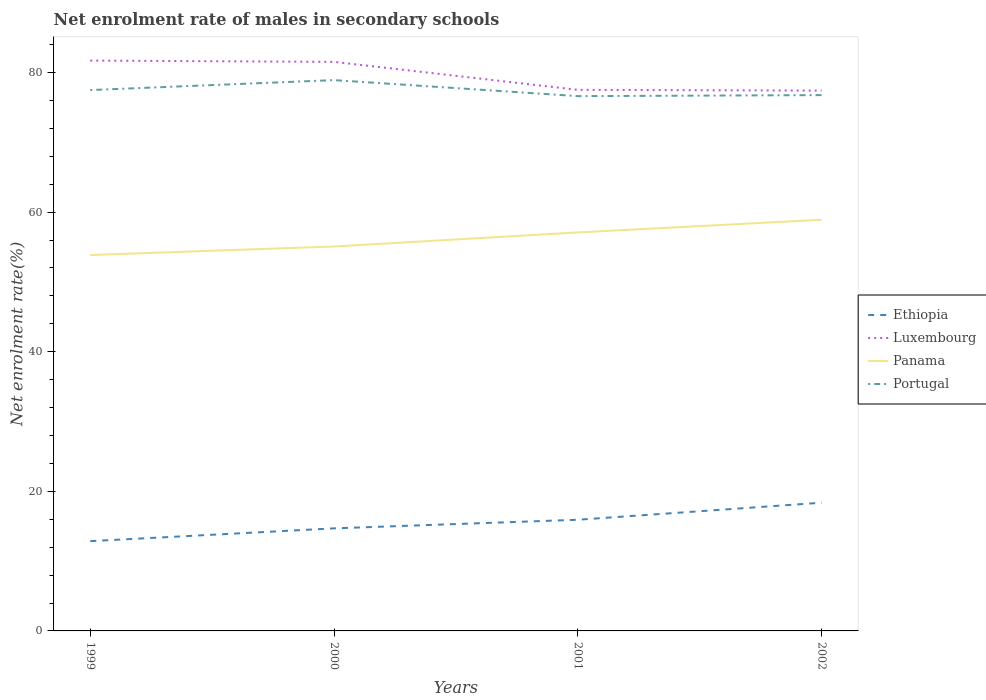Does the line corresponding to Panama intersect with the line corresponding to Portugal?
Provide a succinct answer. No. Is the number of lines equal to the number of legend labels?
Offer a very short reply. Yes. Across all years, what is the maximum net enrolment rate of males in secondary schools in Luxembourg?
Your answer should be compact. 77.42. What is the total net enrolment rate of males in secondary schools in Luxembourg in the graph?
Provide a short and direct response. 0.11. What is the difference between the highest and the second highest net enrolment rate of males in secondary schools in Ethiopia?
Offer a terse response. 5.51. What is the difference between the highest and the lowest net enrolment rate of males in secondary schools in Panama?
Your answer should be compact. 2. Is the net enrolment rate of males in secondary schools in Luxembourg strictly greater than the net enrolment rate of males in secondary schools in Portugal over the years?
Keep it short and to the point. No. What is the difference between two consecutive major ticks on the Y-axis?
Ensure brevity in your answer.  20. Does the graph contain any zero values?
Make the answer very short. No. Does the graph contain grids?
Provide a succinct answer. No. Where does the legend appear in the graph?
Make the answer very short. Center right. How are the legend labels stacked?
Give a very brief answer. Vertical. What is the title of the graph?
Your answer should be compact. Net enrolment rate of males in secondary schools. What is the label or title of the X-axis?
Give a very brief answer. Years. What is the label or title of the Y-axis?
Make the answer very short. Net enrolment rate(%). What is the Net enrolment rate(%) of Ethiopia in 1999?
Your answer should be compact. 12.86. What is the Net enrolment rate(%) of Luxembourg in 1999?
Make the answer very short. 81.71. What is the Net enrolment rate(%) in Panama in 1999?
Offer a very short reply. 53.86. What is the Net enrolment rate(%) in Portugal in 1999?
Your answer should be compact. 77.49. What is the Net enrolment rate(%) of Ethiopia in 2000?
Keep it short and to the point. 14.7. What is the Net enrolment rate(%) in Luxembourg in 2000?
Offer a terse response. 81.53. What is the Net enrolment rate(%) of Panama in 2000?
Your response must be concise. 55.08. What is the Net enrolment rate(%) of Portugal in 2000?
Give a very brief answer. 78.92. What is the Net enrolment rate(%) in Ethiopia in 2001?
Make the answer very short. 15.93. What is the Net enrolment rate(%) in Luxembourg in 2001?
Ensure brevity in your answer.  77.53. What is the Net enrolment rate(%) in Panama in 2001?
Offer a terse response. 57.1. What is the Net enrolment rate(%) in Portugal in 2001?
Offer a very short reply. 76.62. What is the Net enrolment rate(%) of Ethiopia in 2002?
Keep it short and to the point. 18.37. What is the Net enrolment rate(%) of Luxembourg in 2002?
Keep it short and to the point. 77.42. What is the Net enrolment rate(%) of Panama in 2002?
Your response must be concise. 58.91. What is the Net enrolment rate(%) in Portugal in 2002?
Provide a succinct answer. 76.77. Across all years, what is the maximum Net enrolment rate(%) of Ethiopia?
Your answer should be very brief. 18.37. Across all years, what is the maximum Net enrolment rate(%) of Luxembourg?
Provide a short and direct response. 81.71. Across all years, what is the maximum Net enrolment rate(%) in Panama?
Ensure brevity in your answer.  58.91. Across all years, what is the maximum Net enrolment rate(%) in Portugal?
Your answer should be very brief. 78.92. Across all years, what is the minimum Net enrolment rate(%) of Ethiopia?
Provide a succinct answer. 12.86. Across all years, what is the minimum Net enrolment rate(%) of Luxembourg?
Provide a succinct answer. 77.42. Across all years, what is the minimum Net enrolment rate(%) of Panama?
Your answer should be compact. 53.86. Across all years, what is the minimum Net enrolment rate(%) of Portugal?
Offer a very short reply. 76.62. What is the total Net enrolment rate(%) in Ethiopia in the graph?
Keep it short and to the point. 61.86. What is the total Net enrolment rate(%) in Luxembourg in the graph?
Offer a terse response. 318.19. What is the total Net enrolment rate(%) of Panama in the graph?
Provide a succinct answer. 224.95. What is the total Net enrolment rate(%) in Portugal in the graph?
Your answer should be compact. 309.8. What is the difference between the Net enrolment rate(%) of Ethiopia in 1999 and that in 2000?
Provide a short and direct response. -1.83. What is the difference between the Net enrolment rate(%) in Luxembourg in 1999 and that in 2000?
Keep it short and to the point. 0.18. What is the difference between the Net enrolment rate(%) of Panama in 1999 and that in 2000?
Provide a short and direct response. -1.22. What is the difference between the Net enrolment rate(%) of Portugal in 1999 and that in 2000?
Ensure brevity in your answer.  -1.43. What is the difference between the Net enrolment rate(%) in Ethiopia in 1999 and that in 2001?
Your answer should be compact. -3.07. What is the difference between the Net enrolment rate(%) of Luxembourg in 1999 and that in 2001?
Your response must be concise. 4.19. What is the difference between the Net enrolment rate(%) in Panama in 1999 and that in 2001?
Offer a terse response. -3.24. What is the difference between the Net enrolment rate(%) of Portugal in 1999 and that in 2001?
Give a very brief answer. 0.87. What is the difference between the Net enrolment rate(%) in Ethiopia in 1999 and that in 2002?
Offer a terse response. -5.51. What is the difference between the Net enrolment rate(%) of Luxembourg in 1999 and that in 2002?
Offer a very short reply. 4.3. What is the difference between the Net enrolment rate(%) in Panama in 1999 and that in 2002?
Provide a succinct answer. -5.05. What is the difference between the Net enrolment rate(%) in Portugal in 1999 and that in 2002?
Provide a short and direct response. 0.72. What is the difference between the Net enrolment rate(%) in Ethiopia in 2000 and that in 2001?
Your answer should be compact. -1.23. What is the difference between the Net enrolment rate(%) in Luxembourg in 2000 and that in 2001?
Your response must be concise. 4.01. What is the difference between the Net enrolment rate(%) in Panama in 2000 and that in 2001?
Your answer should be very brief. -2.02. What is the difference between the Net enrolment rate(%) of Portugal in 2000 and that in 2001?
Ensure brevity in your answer.  2.3. What is the difference between the Net enrolment rate(%) in Ethiopia in 2000 and that in 2002?
Give a very brief answer. -3.68. What is the difference between the Net enrolment rate(%) in Luxembourg in 2000 and that in 2002?
Your response must be concise. 4.12. What is the difference between the Net enrolment rate(%) of Panama in 2000 and that in 2002?
Your answer should be compact. -3.83. What is the difference between the Net enrolment rate(%) of Portugal in 2000 and that in 2002?
Your response must be concise. 2.15. What is the difference between the Net enrolment rate(%) in Ethiopia in 2001 and that in 2002?
Provide a succinct answer. -2.44. What is the difference between the Net enrolment rate(%) in Luxembourg in 2001 and that in 2002?
Ensure brevity in your answer.  0.11. What is the difference between the Net enrolment rate(%) of Panama in 2001 and that in 2002?
Provide a short and direct response. -1.82. What is the difference between the Net enrolment rate(%) of Portugal in 2001 and that in 2002?
Give a very brief answer. -0.15. What is the difference between the Net enrolment rate(%) in Ethiopia in 1999 and the Net enrolment rate(%) in Luxembourg in 2000?
Offer a terse response. -68.67. What is the difference between the Net enrolment rate(%) of Ethiopia in 1999 and the Net enrolment rate(%) of Panama in 2000?
Ensure brevity in your answer.  -42.22. What is the difference between the Net enrolment rate(%) of Ethiopia in 1999 and the Net enrolment rate(%) of Portugal in 2000?
Offer a terse response. -66.06. What is the difference between the Net enrolment rate(%) in Luxembourg in 1999 and the Net enrolment rate(%) in Panama in 2000?
Your answer should be compact. 26.63. What is the difference between the Net enrolment rate(%) of Luxembourg in 1999 and the Net enrolment rate(%) of Portugal in 2000?
Provide a short and direct response. 2.8. What is the difference between the Net enrolment rate(%) of Panama in 1999 and the Net enrolment rate(%) of Portugal in 2000?
Provide a short and direct response. -25.06. What is the difference between the Net enrolment rate(%) in Ethiopia in 1999 and the Net enrolment rate(%) in Luxembourg in 2001?
Your response must be concise. -64.66. What is the difference between the Net enrolment rate(%) of Ethiopia in 1999 and the Net enrolment rate(%) of Panama in 2001?
Provide a short and direct response. -44.23. What is the difference between the Net enrolment rate(%) in Ethiopia in 1999 and the Net enrolment rate(%) in Portugal in 2001?
Provide a short and direct response. -63.76. What is the difference between the Net enrolment rate(%) of Luxembourg in 1999 and the Net enrolment rate(%) of Panama in 2001?
Offer a terse response. 24.62. What is the difference between the Net enrolment rate(%) in Luxembourg in 1999 and the Net enrolment rate(%) in Portugal in 2001?
Offer a terse response. 5.09. What is the difference between the Net enrolment rate(%) of Panama in 1999 and the Net enrolment rate(%) of Portugal in 2001?
Make the answer very short. -22.76. What is the difference between the Net enrolment rate(%) in Ethiopia in 1999 and the Net enrolment rate(%) in Luxembourg in 2002?
Give a very brief answer. -64.55. What is the difference between the Net enrolment rate(%) of Ethiopia in 1999 and the Net enrolment rate(%) of Panama in 2002?
Make the answer very short. -46.05. What is the difference between the Net enrolment rate(%) of Ethiopia in 1999 and the Net enrolment rate(%) of Portugal in 2002?
Keep it short and to the point. -63.91. What is the difference between the Net enrolment rate(%) of Luxembourg in 1999 and the Net enrolment rate(%) of Panama in 2002?
Keep it short and to the point. 22.8. What is the difference between the Net enrolment rate(%) in Luxembourg in 1999 and the Net enrolment rate(%) in Portugal in 2002?
Ensure brevity in your answer.  4.94. What is the difference between the Net enrolment rate(%) in Panama in 1999 and the Net enrolment rate(%) in Portugal in 2002?
Offer a terse response. -22.91. What is the difference between the Net enrolment rate(%) of Ethiopia in 2000 and the Net enrolment rate(%) of Luxembourg in 2001?
Ensure brevity in your answer.  -62.83. What is the difference between the Net enrolment rate(%) in Ethiopia in 2000 and the Net enrolment rate(%) in Panama in 2001?
Make the answer very short. -42.4. What is the difference between the Net enrolment rate(%) in Ethiopia in 2000 and the Net enrolment rate(%) in Portugal in 2001?
Offer a terse response. -61.93. What is the difference between the Net enrolment rate(%) in Luxembourg in 2000 and the Net enrolment rate(%) in Panama in 2001?
Provide a short and direct response. 24.44. What is the difference between the Net enrolment rate(%) of Luxembourg in 2000 and the Net enrolment rate(%) of Portugal in 2001?
Provide a succinct answer. 4.91. What is the difference between the Net enrolment rate(%) in Panama in 2000 and the Net enrolment rate(%) in Portugal in 2001?
Your response must be concise. -21.54. What is the difference between the Net enrolment rate(%) of Ethiopia in 2000 and the Net enrolment rate(%) of Luxembourg in 2002?
Keep it short and to the point. -62.72. What is the difference between the Net enrolment rate(%) of Ethiopia in 2000 and the Net enrolment rate(%) of Panama in 2002?
Your response must be concise. -44.22. What is the difference between the Net enrolment rate(%) in Ethiopia in 2000 and the Net enrolment rate(%) in Portugal in 2002?
Offer a very short reply. -62.08. What is the difference between the Net enrolment rate(%) of Luxembourg in 2000 and the Net enrolment rate(%) of Panama in 2002?
Ensure brevity in your answer.  22.62. What is the difference between the Net enrolment rate(%) in Luxembourg in 2000 and the Net enrolment rate(%) in Portugal in 2002?
Give a very brief answer. 4.76. What is the difference between the Net enrolment rate(%) in Panama in 2000 and the Net enrolment rate(%) in Portugal in 2002?
Ensure brevity in your answer.  -21.69. What is the difference between the Net enrolment rate(%) of Ethiopia in 2001 and the Net enrolment rate(%) of Luxembourg in 2002?
Your answer should be compact. -61.49. What is the difference between the Net enrolment rate(%) in Ethiopia in 2001 and the Net enrolment rate(%) in Panama in 2002?
Your answer should be compact. -42.98. What is the difference between the Net enrolment rate(%) in Ethiopia in 2001 and the Net enrolment rate(%) in Portugal in 2002?
Your answer should be compact. -60.84. What is the difference between the Net enrolment rate(%) of Luxembourg in 2001 and the Net enrolment rate(%) of Panama in 2002?
Ensure brevity in your answer.  18.61. What is the difference between the Net enrolment rate(%) in Luxembourg in 2001 and the Net enrolment rate(%) in Portugal in 2002?
Provide a succinct answer. 0.75. What is the difference between the Net enrolment rate(%) of Panama in 2001 and the Net enrolment rate(%) of Portugal in 2002?
Your response must be concise. -19.68. What is the average Net enrolment rate(%) in Ethiopia per year?
Offer a very short reply. 15.46. What is the average Net enrolment rate(%) in Luxembourg per year?
Ensure brevity in your answer.  79.55. What is the average Net enrolment rate(%) of Panama per year?
Your response must be concise. 56.24. What is the average Net enrolment rate(%) in Portugal per year?
Your response must be concise. 77.45. In the year 1999, what is the difference between the Net enrolment rate(%) in Ethiopia and Net enrolment rate(%) in Luxembourg?
Offer a terse response. -68.85. In the year 1999, what is the difference between the Net enrolment rate(%) of Ethiopia and Net enrolment rate(%) of Panama?
Provide a short and direct response. -41. In the year 1999, what is the difference between the Net enrolment rate(%) of Ethiopia and Net enrolment rate(%) of Portugal?
Provide a succinct answer. -64.63. In the year 1999, what is the difference between the Net enrolment rate(%) in Luxembourg and Net enrolment rate(%) in Panama?
Offer a terse response. 27.85. In the year 1999, what is the difference between the Net enrolment rate(%) of Luxembourg and Net enrolment rate(%) of Portugal?
Make the answer very short. 4.22. In the year 1999, what is the difference between the Net enrolment rate(%) of Panama and Net enrolment rate(%) of Portugal?
Provide a short and direct response. -23.63. In the year 2000, what is the difference between the Net enrolment rate(%) in Ethiopia and Net enrolment rate(%) in Luxembourg?
Your answer should be very brief. -66.84. In the year 2000, what is the difference between the Net enrolment rate(%) in Ethiopia and Net enrolment rate(%) in Panama?
Offer a very short reply. -40.38. In the year 2000, what is the difference between the Net enrolment rate(%) of Ethiopia and Net enrolment rate(%) of Portugal?
Ensure brevity in your answer.  -64.22. In the year 2000, what is the difference between the Net enrolment rate(%) in Luxembourg and Net enrolment rate(%) in Panama?
Offer a very short reply. 26.45. In the year 2000, what is the difference between the Net enrolment rate(%) in Luxembourg and Net enrolment rate(%) in Portugal?
Your answer should be very brief. 2.62. In the year 2000, what is the difference between the Net enrolment rate(%) in Panama and Net enrolment rate(%) in Portugal?
Offer a very short reply. -23.84. In the year 2001, what is the difference between the Net enrolment rate(%) of Ethiopia and Net enrolment rate(%) of Luxembourg?
Give a very brief answer. -61.6. In the year 2001, what is the difference between the Net enrolment rate(%) of Ethiopia and Net enrolment rate(%) of Panama?
Provide a short and direct response. -41.17. In the year 2001, what is the difference between the Net enrolment rate(%) of Ethiopia and Net enrolment rate(%) of Portugal?
Your response must be concise. -60.69. In the year 2001, what is the difference between the Net enrolment rate(%) in Luxembourg and Net enrolment rate(%) in Panama?
Ensure brevity in your answer.  20.43. In the year 2001, what is the difference between the Net enrolment rate(%) in Luxembourg and Net enrolment rate(%) in Portugal?
Offer a very short reply. 0.9. In the year 2001, what is the difference between the Net enrolment rate(%) of Panama and Net enrolment rate(%) of Portugal?
Provide a succinct answer. -19.53. In the year 2002, what is the difference between the Net enrolment rate(%) in Ethiopia and Net enrolment rate(%) in Luxembourg?
Your response must be concise. -59.05. In the year 2002, what is the difference between the Net enrolment rate(%) of Ethiopia and Net enrolment rate(%) of Panama?
Give a very brief answer. -40.54. In the year 2002, what is the difference between the Net enrolment rate(%) in Ethiopia and Net enrolment rate(%) in Portugal?
Keep it short and to the point. -58.4. In the year 2002, what is the difference between the Net enrolment rate(%) in Luxembourg and Net enrolment rate(%) in Panama?
Your answer should be very brief. 18.5. In the year 2002, what is the difference between the Net enrolment rate(%) of Luxembourg and Net enrolment rate(%) of Portugal?
Offer a terse response. 0.64. In the year 2002, what is the difference between the Net enrolment rate(%) in Panama and Net enrolment rate(%) in Portugal?
Provide a succinct answer. -17.86. What is the ratio of the Net enrolment rate(%) of Ethiopia in 1999 to that in 2000?
Provide a short and direct response. 0.88. What is the ratio of the Net enrolment rate(%) in Luxembourg in 1999 to that in 2000?
Offer a very short reply. 1. What is the ratio of the Net enrolment rate(%) of Panama in 1999 to that in 2000?
Give a very brief answer. 0.98. What is the ratio of the Net enrolment rate(%) in Portugal in 1999 to that in 2000?
Provide a succinct answer. 0.98. What is the ratio of the Net enrolment rate(%) in Ethiopia in 1999 to that in 2001?
Offer a terse response. 0.81. What is the ratio of the Net enrolment rate(%) in Luxembourg in 1999 to that in 2001?
Your answer should be very brief. 1.05. What is the ratio of the Net enrolment rate(%) in Panama in 1999 to that in 2001?
Your answer should be very brief. 0.94. What is the ratio of the Net enrolment rate(%) in Portugal in 1999 to that in 2001?
Ensure brevity in your answer.  1.01. What is the ratio of the Net enrolment rate(%) in Ethiopia in 1999 to that in 2002?
Make the answer very short. 0.7. What is the ratio of the Net enrolment rate(%) of Luxembourg in 1999 to that in 2002?
Your response must be concise. 1.06. What is the ratio of the Net enrolment rate(%) of Panama in 1999 to that in 2002?
Make the answer very short. 0.91. What is the ratio of the Net enrolment rate(%) of Portugal in 1999 to that in 2002?
Offer a terse response. 1.01. What is the ratio of the Net enrolment rate(%) in Ethiopia in 2000 to that in 2001?
Provide a short and direct response. 0.92. What is the ratio of the Net enrolment rate(%) in Luxembourg in 2000 to that in 2001?
Offer a terse response. 1.05. What is the ratio of the Net enrolment rate(%) of Panama in 2000 to that in 2001?
Make the answer very short. 0.96. What is the ratio of the Net enrolment rate(%) in Portugal in 2000 to that in 2001?
Give a very brief answer. 1.03. What is the ratio of the Net enrolment rate(%) in Ethiopia in 2000 to that in 2002?
Give a very brief answer. 0.8. What is the ratio of the Net enrolment rate(%) of Luxembourg in 2000 to that in 2002?
Your answer should be compact. 1.05. What is the ratio of the Net enrolment rate(%) in Panama in 2000 to that in 2002?
Provide a short and direct response. 0.94. What is the ratio of the Net enrolment rate(%) of Portugal in 2000 to that in 2002?
Offer a very short reply. 1.03. What is the ratio of the Net enrolment rate(%) of Ethiopia in 2001 to that in 2002?
Your answer should be compact. 0.87. What is the ratio of the Net enrolment rate(%) in Luxembourg in 2001 to that in 2002?
Give a very brief answer. 1. What is the ratio of the Net enrolment rate(%) of Panama in 2001 to that in 2002?
Your response must be concise. 0.97. What is the difference between the highest and the second highest Net enrolment rate(%) in Ethiopia?
Offer a very short reply. 2.44. What is the difference between the highest and the second highest Net enrolment rate(%) in Luxembourg?
Ensure brevity in your answer.  0.18. What is the difference between the highest and the second highest Net enrolment rate(%) of Panama?
Provide a succinct answer. 1.82. What is the difference between the highest and the second highest Net enrolment rate(%) of Portugal?
Provide a short and direct response. 1.43. What is the difference between the highest and the lowest Net enrolment rate(%) of Ethiopia?
Give a very brief answer. 5.51. What is the difference between the highest and the lowest Net enrolment rate(%) of Luxembourg?
Make the answer very short. 4.3. What is the difference between the highest and the lowest Net enrolment rate(%) of Panama?
Keep it short and to the point. 5.05. What is the difference between the highest and the lowest Net enrolment rate(%) of Portugal?
Your answer should be compact. 2.3. 